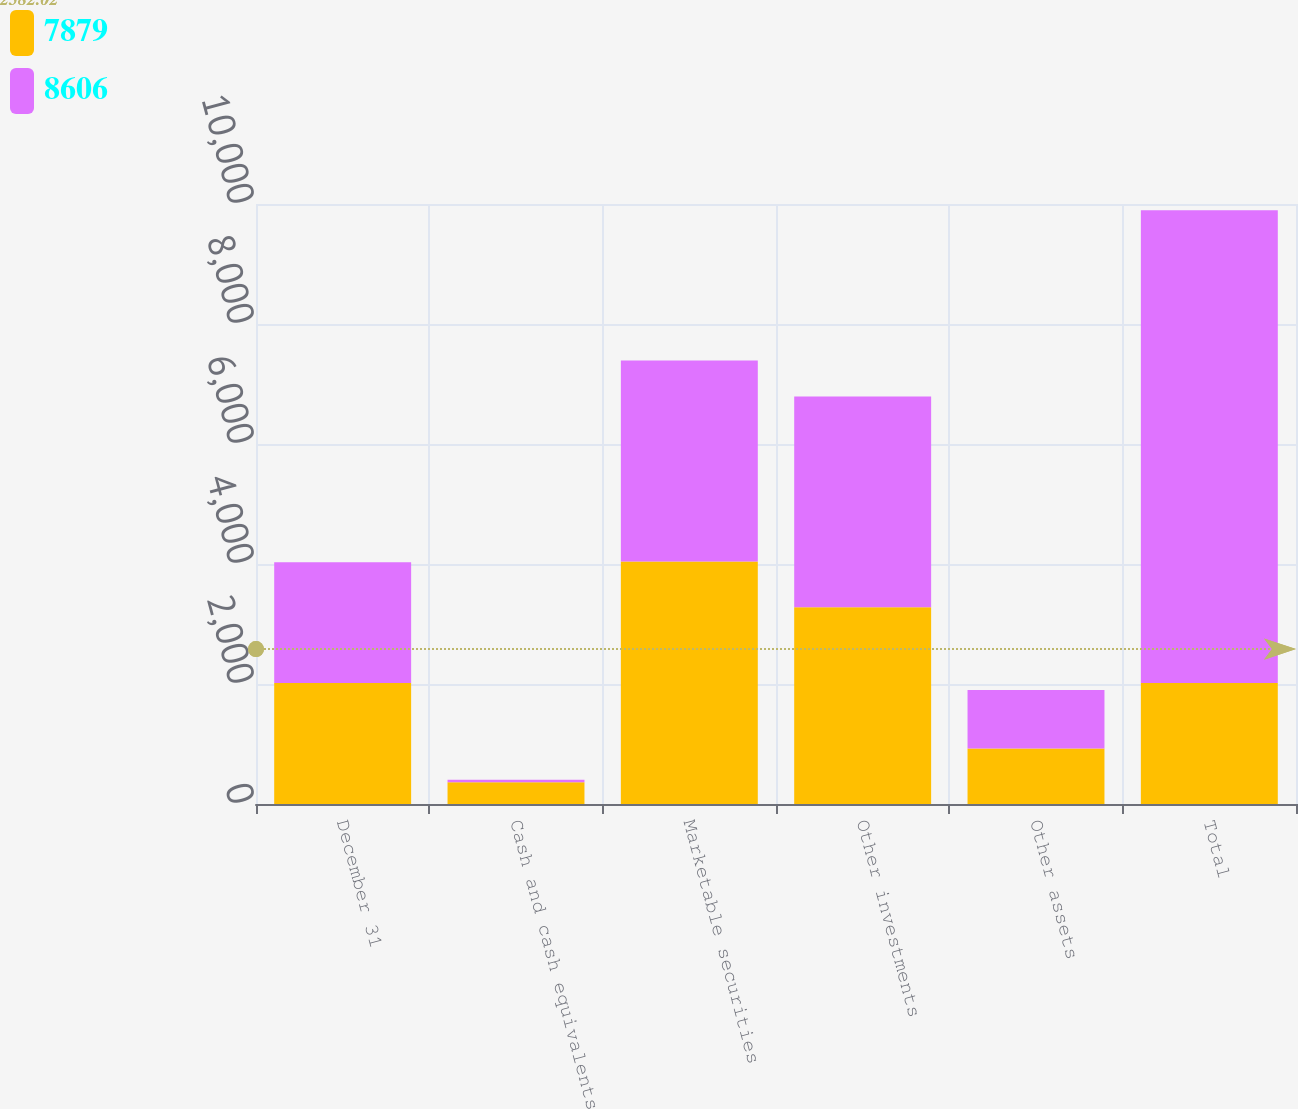Convert chart. <chart><loc_0><loc_0><loc_500><loc_500><stacked_bar_chart><ecel><fcel>December 31<fcel>Cash and cash equivalents<fcel>Marketable securities<fcel>Other investments<fcel>Other assets<fcel>Total<nl><fcel>7879<fcel>2015<fcel>361<fcel>4040<fcel>3280<fcel>925<fcel>2015<nl><fcel>8606<fcel>2014<fcel>43<fcel>3350<fcel>3512<fcel>974<fcel>7879<nl></chart> 